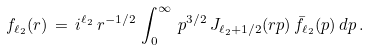<formula> <loc_0><loc_0><loc_500><loc_500>f _ { \ell _ { 2 } } ( r ) \, = \, i ^ { \ell _ { 2 } } \, r ^ { - 1 / 2 } \, \int _ { 0 } ^ { \infty } \, p ^ { 3 / 2 } \, J _ { \ell _ { 2 } + 1 / 2 } ( r p ) \, \bar { f } _ { \ell _ { 2 } } ( p ) \, d p \, .</formula> 